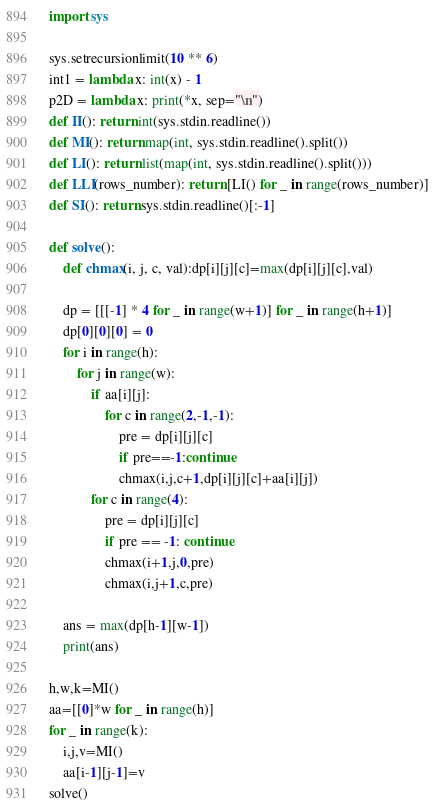Convert code to text. <code><loc_0><loc_0><loc_500><loc_500><_Python_>import sys

sys.setrecursionlimit(10 ** 6)
int1 = lambda x: int(x) - 1
p2D = lambda x: print(*x, sep="\n")
def II(): return int(sys.stdin.readline())
def MI(): return map(int, sys.stdin.readline().split())
def LI(): return list(map(int, sys.stdin.readline().split()))
def LLI(rows_number): return [LI() for _ in range(rows_number)]
def SI(): return sys.stdin.readline()[:-1]

def solve():
    def chmax(i, j, c, val):dp[i][j][c]=max(dp[i][j][c],val)

    dp = [[[-1] * 4 for _ in range(w+1)] for _ in range(h+1)]
    dp[0][0][0] = 0
    for i in range(h):
        for j in range(w):
            if aa[i][j]:
                for c in range(2,-1,-1):
                    pre = dp[i][j][c]
                    if pre==-1:continue
                    chmax(i,j,c+1,dp[i][j][c]+aa[i][j])
            for c in range(4):
                pre = dp[i][j][c]
                if pre == -1: continue
                chmax(i+1,j,0,pre)
                chmax(i,j+1,c,pre)

    ans = max(dp[h-1][w-1])
    print(ans)

h,w,k=MI()
aa=[[0]*w for _ in range(h)]
for _ in range(k):
    i,j,v=MI()
    aa[i-1][j-1]=v
solve()
</code> 